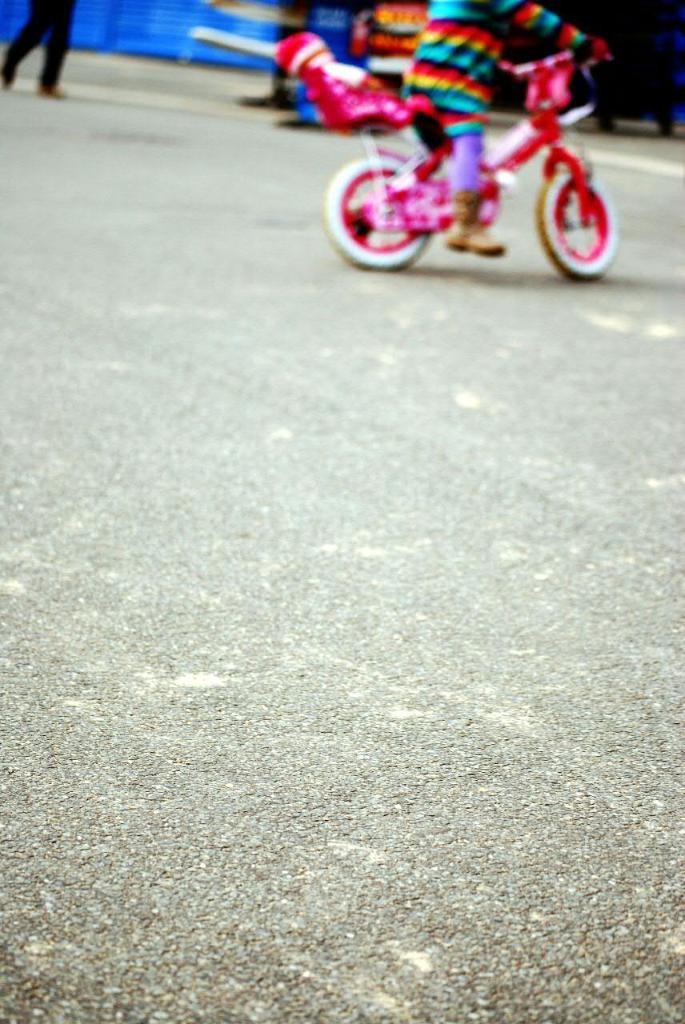Where was the image taken? The image is taken outdoors. What can be seen at the bottom of the image? There is a road at the bottom of the image. What is the person in the image doing? There is a person walking on the road. What activity is the kid involved in? There is a kid playing with a bicycle. How many stitches are required to fix the jar in the image? There is no jar or any indication of needing stitches in the image. 